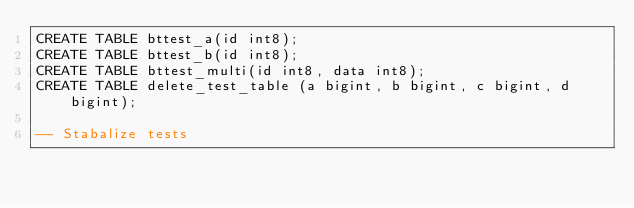<code> <loc_0><loc_0><loc_500><loc_500><_SQL_>CREATE TABLE bttest_a(id int8);
CREATE TABLE bttest_b(id int8);
CREATE TABLE bttest_multi(id int8, data int8);
CREATE TABLE delete_test_table (a bigint, b bigint, c bigint, d bigint);

-- Stabalize tests</code> 